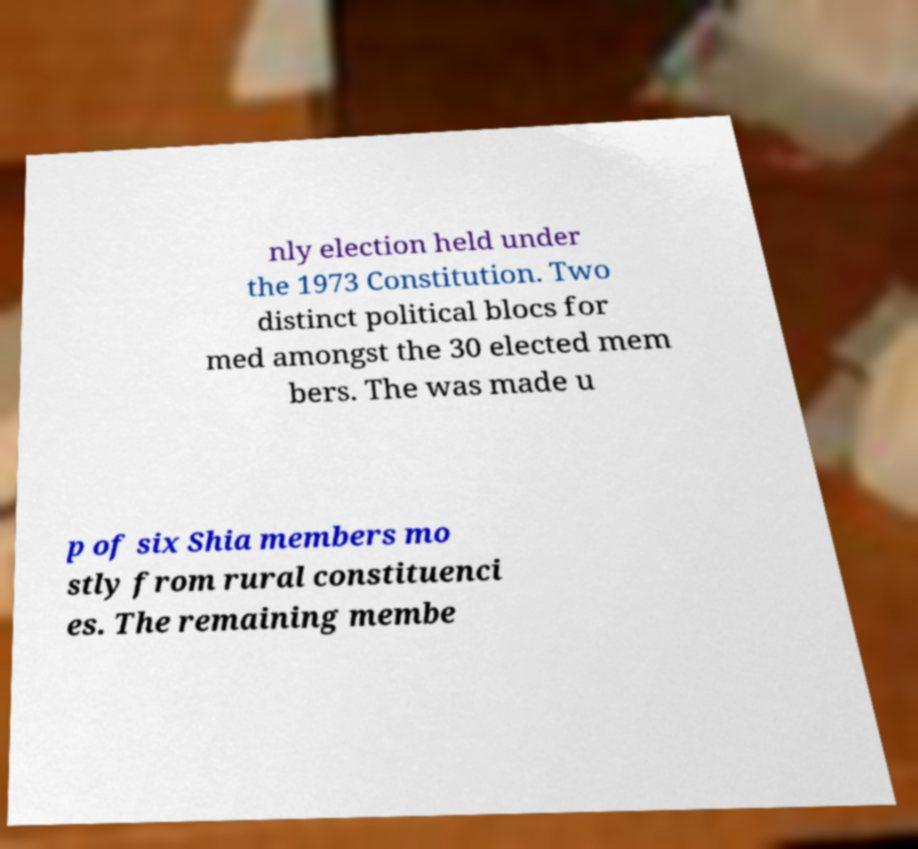I need the written content from this picture converted into text. Can you do that? nly election held under the 1973 Constitution. Two distinct political blocs for med amongst the 30 elected mem bers. The was made u p of six Shia members mo stly from rural constituenci es. The remaining membe 